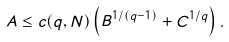<formula> <loc_0><loc_0><loc_500><loc_500>A \leq c ( q , N ) \left ( B ^ { 1 / ( q - 1 ) } + C ^ { 1 / q } \right ) .</formula> 